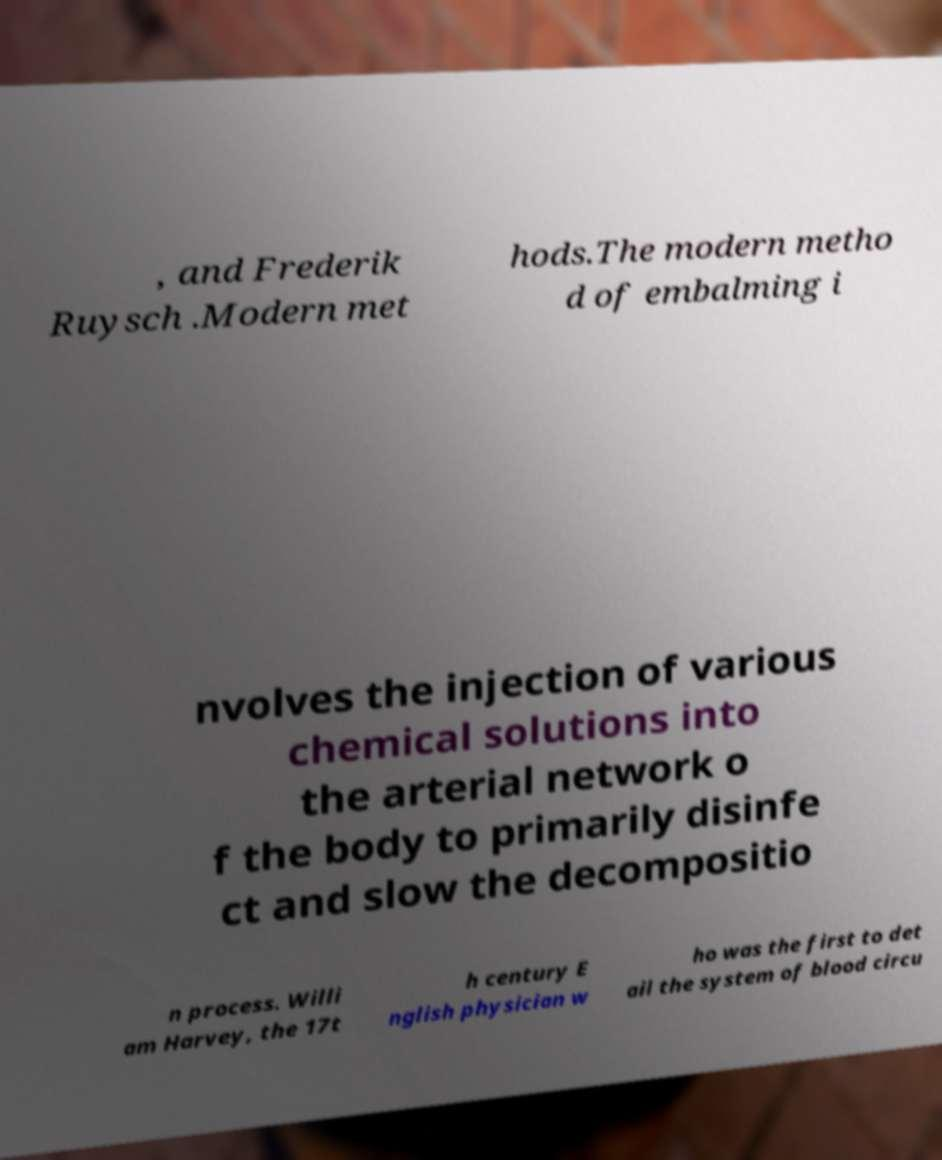For documentation purposes, I need the text within this image transcribed. Could you provide that? , and Frederik Ruysch .Modern met hods.The modern metho d of embalming i nvolves the injection of various chemical solutions into the arterial network o f the body to primarily disinfe ct and slow the decompositio n process. Willi am Harvey, the 17t h century E nglish physician w ho was the first to det ail the system of blood circu 